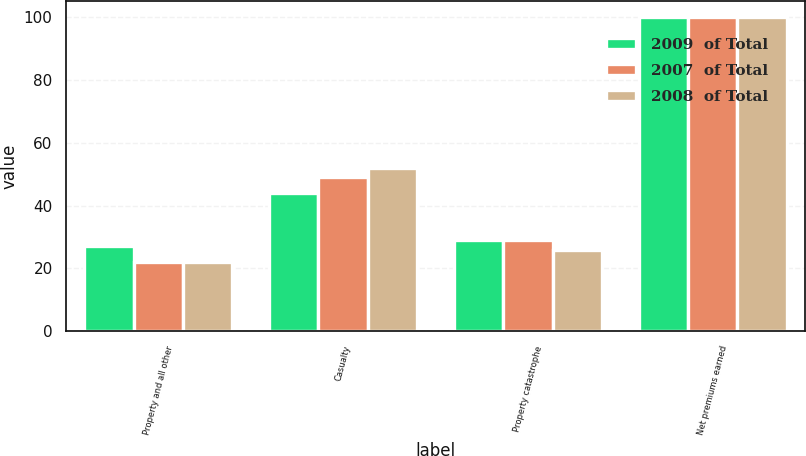Convert chart to OTSL. <chart><loc_0><loc_0><loc_500><loc_500><stacked_bar_chart><ecel><fcel>Property and all other<fcel>Casualty<fcel>Property catastrophe<fcel>Net premiums earned<nl><fcel>2009  of Total<fcel>27<fcel>44<fcel>29<fcel>100<nl><fcel>2007  of Total<fcel>22<fcel>49<fcel>29<fcel>100<nl><fcel>2008  of Total<fcel>22<fcel>52<fcel>26<fcel>100<nl></chart> 